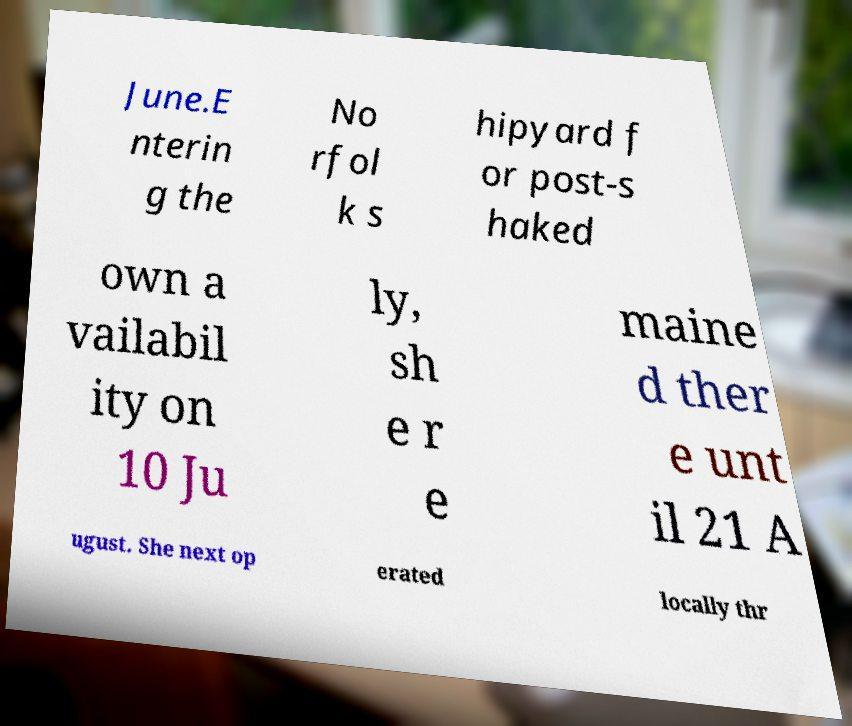Could you extract and type out the text from this image? June.E nterin g the No rfol k s hipyard f or post-s haked own a vailabil ity on 10 Ju ly, sh e r e maine d ther e unt il 21 A ugust. She next op erated locally thr 